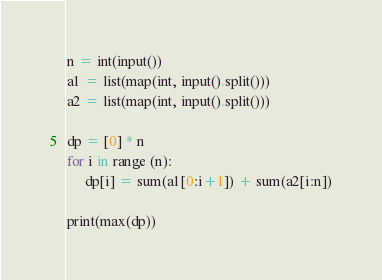<code> <loc_0><loc_0><loc_500><loc_500><_Python_>n = int(input())
a1 = list(map(int, input().split()))
a2 = list(map(int, input().split()))

dp = [0] * n
for i in range (n):
     dp[i] = sum(a1[0:i+1]) + sum(a2[i:n])

print(max(dp))</code> 